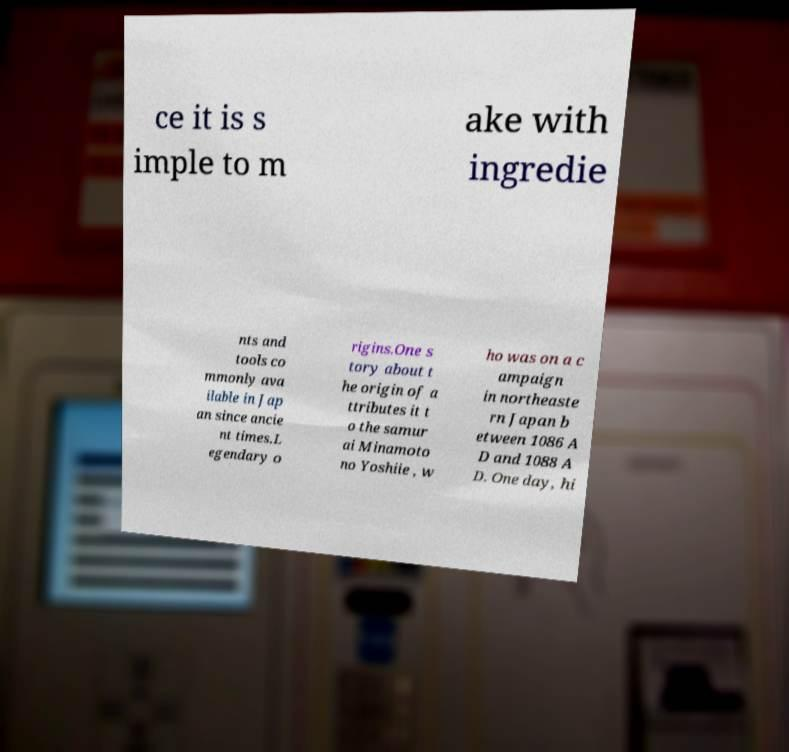I need the written content from this picture converted into text. Can you do that? ce it is s imple to m ake with ingredie nts and tools co mmonly ava ilable in Jap an since ancie nt times.L egendary o rigins.One s tory about t he origin of a ttributes it t o the samur ai Minamoto no Yoshiie , w ho was on a c ampaign in northeaste rn Japan b etween 1086 A D and 1088 A D. One day, hi 